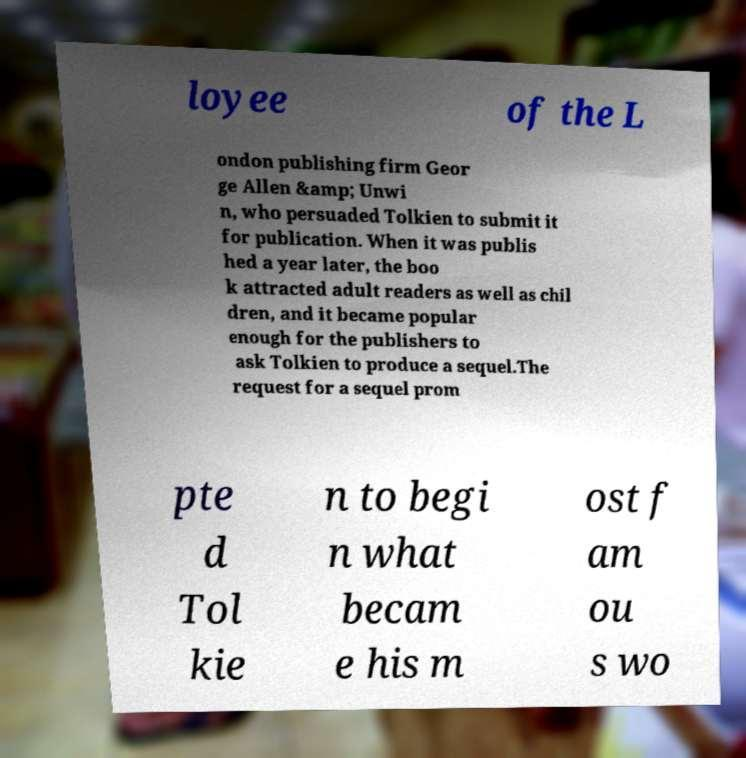Could you extract and type out the text from this image? loyee of the L ondon publishing firm Geor ge Allen &amp; Unwi n, who persuaded Tolkien to submit it for publication. When it was publis hed a year later, the boo k attracted adult readers as well as chil dren, and it became popular enough for the publishers to ask Tolkien to produce a sequel.The request for a sequel prom pte d Tol kie n to begi n what becam e his m ost f am ou s wo 